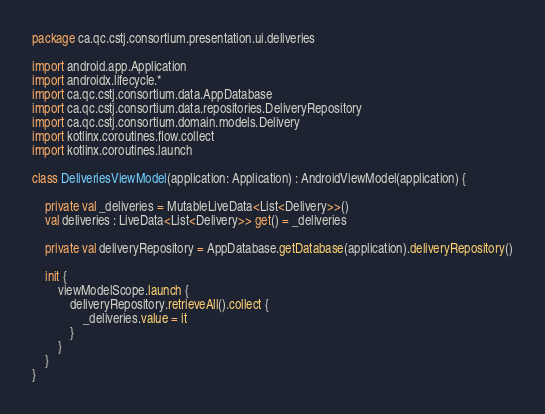<code> <loc_0><loc_0><loc_500><loc_500><_Kotlin_>package ca.qc.cstj.consortium.presentation.ui.deliveries

import android.app.Application
import androidx.lifecycle.*
import ca.qc.cstj.consortium.data.AppDatabase
import ca.qc.cstj.consortium.data.repositories.DeliveryRepository
import ca.qc.cstj.consortium.domain.models.Delivery
import kotlinx.coroutines.flow.collect
import kotlinx.coroutines.launch

class DeliveriesViewModel(application: Application) : AndroidViewModel(application) {

    private val _deliveries = MutableLiveData<List<Delivery>>()
    val deliveries : LiveData<List<Delivery>> get() = _deliveries

    private val deliveryRepository = AppDatabase.getDatabase(application).deliveryRepository()

    init {
        viewModelScope.launch {
            deliveryRepository.retrieveAll().collect {
                _deliveries.value = it
            }
        }
    }
}</code> 